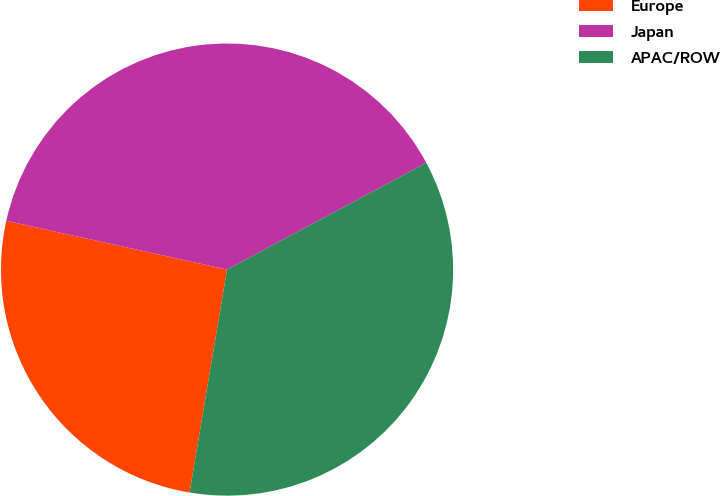<chart> <loc_0><loc_0><loc_500><loc_500><pie_chart><fcel>Europe<fcel>Japan<fcel>APAC/ROW<nl><fcel>25.81%<fcel>38.71%<fcel>35.48%<nl></chart> 